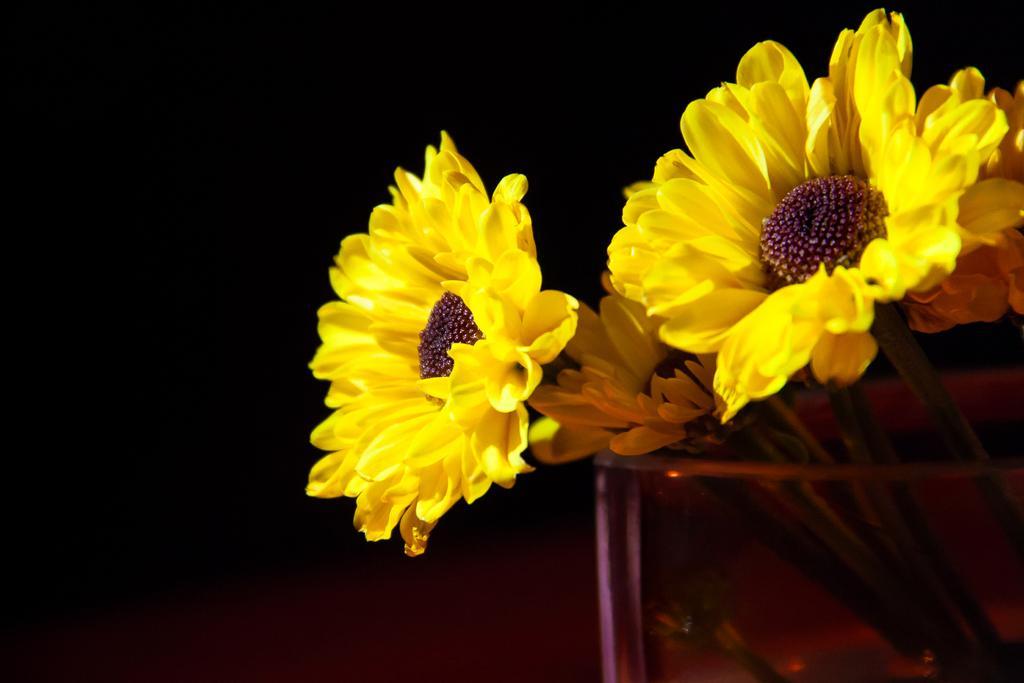Could you give a brief overview of what you see in this image? In this image I can see there are few flowers placed in a glass and the background of the image is dark. 